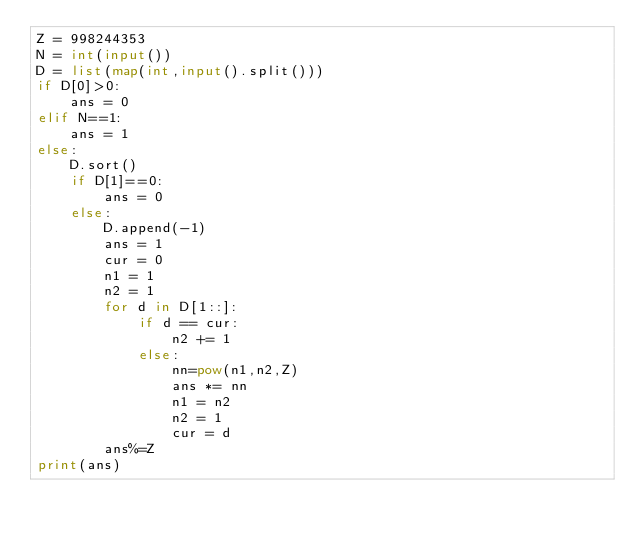<code> <loc_0><loc_0><loc_500><loc_500><_Python_>Z = 998244353
N = int(input())
D = list(map(int,input().split()))
if D[0]>0:
    ans = 0
elif N==1:
    ans = 1
else:
    D.sort()
    if D[1]==0:
        ans = 0
    else:
        D.append(-1)
        ans = 1
        cur = 0
        n1 = 1
        n2 = 1
        for d in D[1::]:
            if d == cur:
                n2 += 1
            else:
                nn=pow(n1,n2,Z)
                ans *= nn
                n1 = n2
                n2 = 1
                cur = d
        ans%=Z
print(ans)</code> 